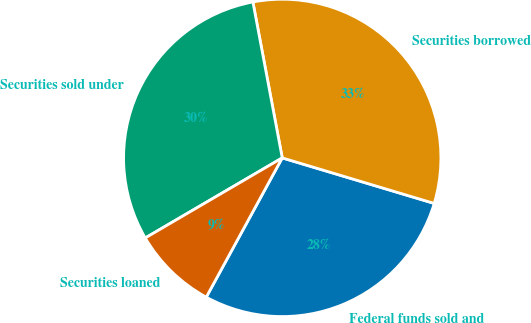<chart> <loc_0><loc_0><loc_500><loc_500><pie_chart><fcel>Federal funds sold and<fcel>Securities borrowed<fcel>Securities sold under<fcel>Securities loaned<nl><fcel>28.32%<fcel>32.6%<fcel>30.46%<fcel>8.63%<nl></chart> 